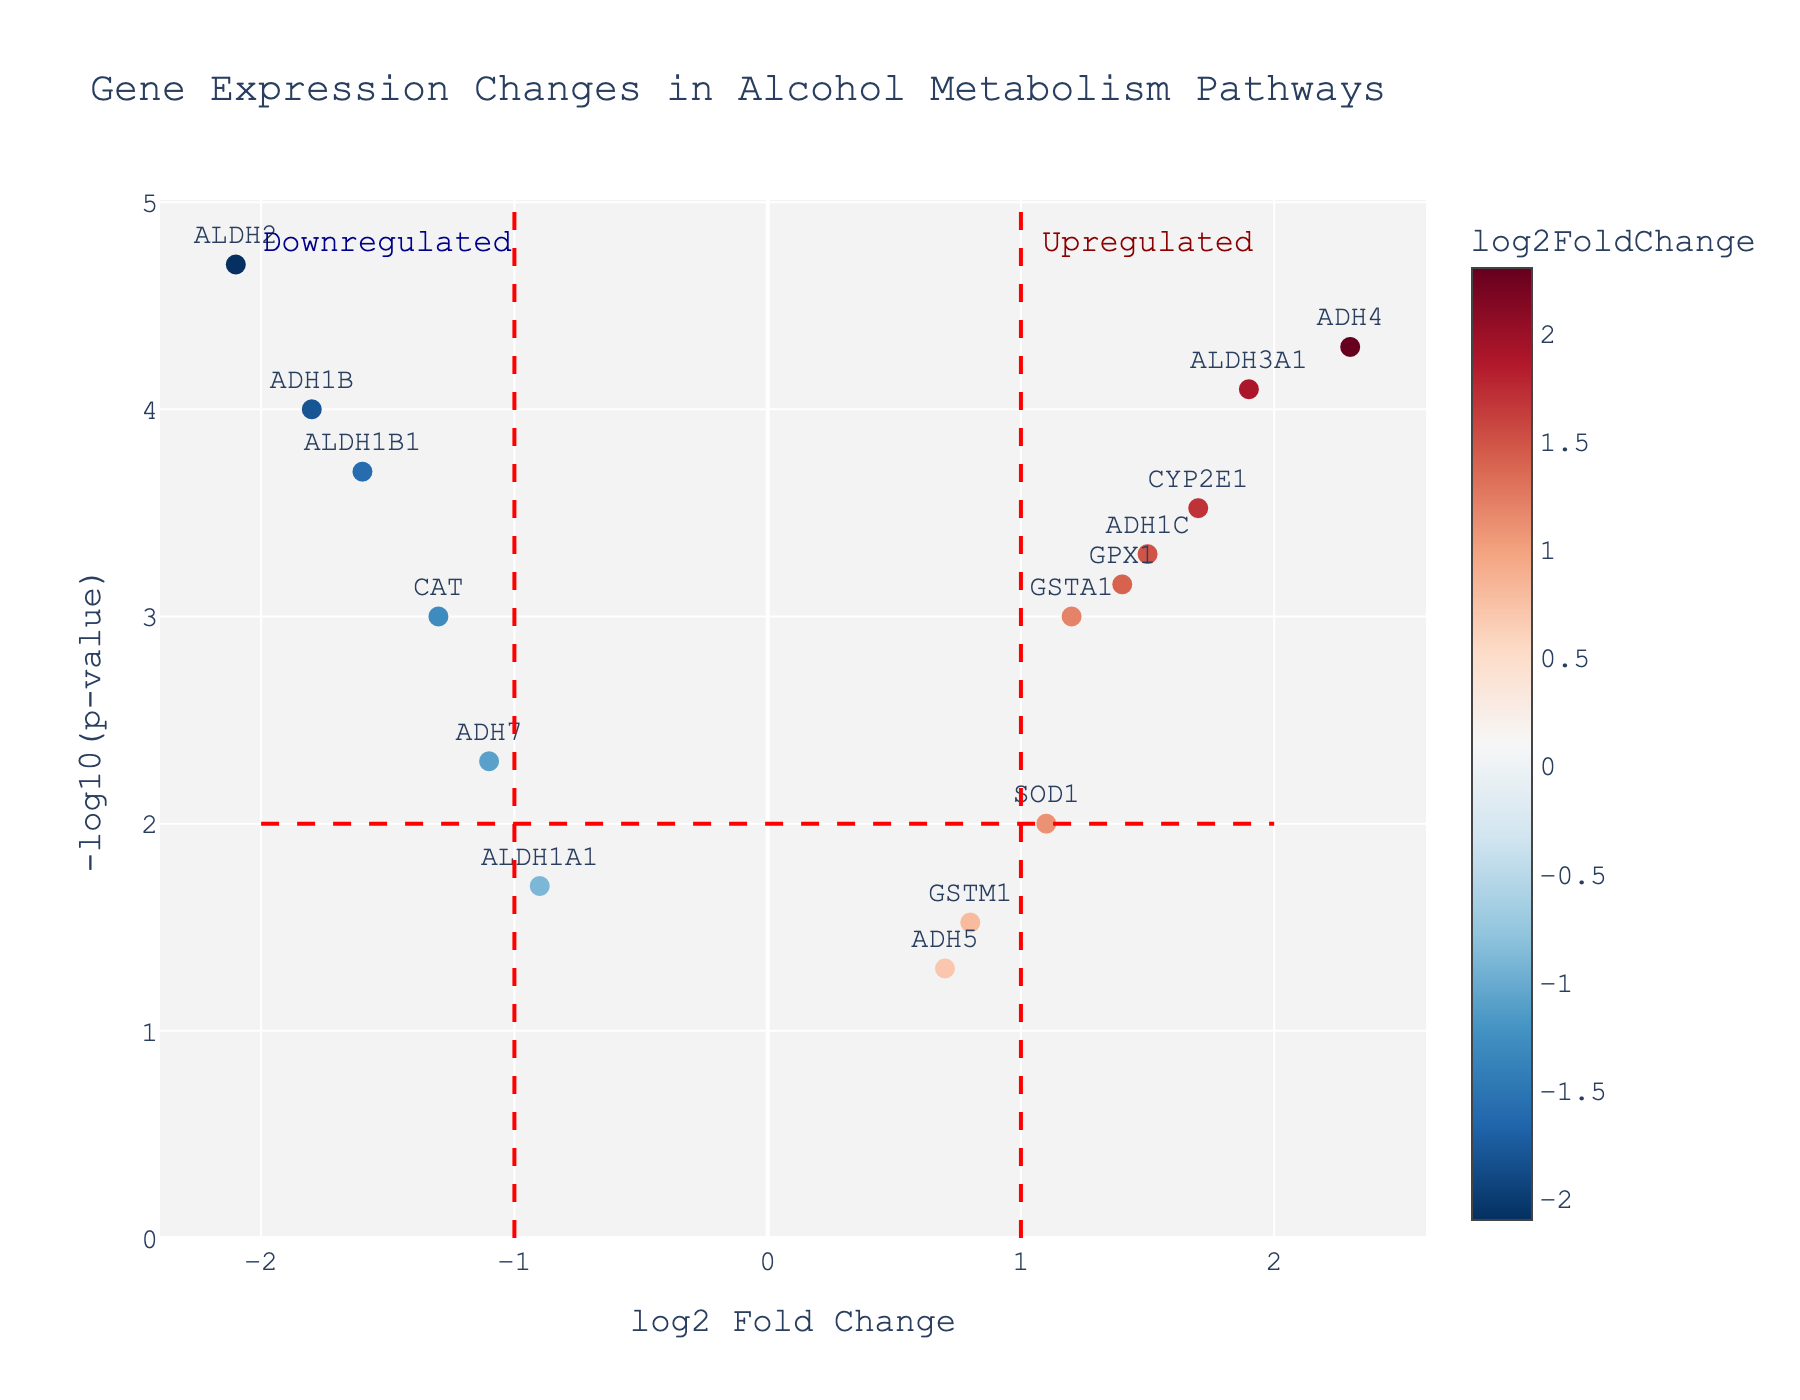What's the title of the plot? The title of the plot is always displayed at the top center of the figure. Here, it says "Gene Expression Changes in Alcohol Metabolism Pathways".
Answer: Gene Expression Changes in Alcohol Metabolism Pathways What do the red dashed lines represent? Red dashed lines on a volcano plot typically indicate significance thresholds. Here, the lines at x=-1 and x=1 represent fold change thresholds, and the line at y=2 represents a p-value threshold of 0.01 (-log10(0.01)).
Answer: Significance thresholds How many genes are upregulated and statistically significant? Upregulated and statistically significant genes are those with a log2FoldChange > 1 and -log10(p-value) > 2. By observing the plot, ADH4, CYP2E1, ADH1C, ALDH3A1, and GPX1 meet these criteria.
Answer: 5 genes Which gene has the highest log2 fold change? The gene with the highest log2 fold change is the one with the highest x-coordinate value. From the plot, we see that ADH4 has the highest log2FoldChange of 2.3.
Answer: ADH4 Are there more upregulated or downregulated genes? To determine this, count the number of genes with positive log2FoldChange (upregulated) and compare it to the number of genes with negative log2FoldChange (downregulated). By examining the points, 7 gene points are upregulated and 8 are downregulated.
Answer: More downregulated What is the p-value of the ADH1B gene? The p-value of a gene can be determined by its y-coordinate which represents -log10(p-value). For ADH1B, the y-coordinate falls around 4, indicating a -log10(p-value) of 4, which translates to p-value = 10^-4.
Answer: 0.0001 Which two genes have the closest log2FoldChange values but different signs? Identify two genes with log2FoldChange values that are numerically similar but opposite in sign. ADH7 (-1.1) and SOD1 (1.1) are the closest in value but have different signs.
Answer: ADH7 and SOD1 Compare the fold changes and p-values of ALDH2 and ALDH1B1. Which gene is more downregulated and more statistically significant? ALDH2 has a log2FoldChange of -2.1 and p-value of 0.00002 (-log10(p-value) = 4.7), while ALDH1B1 has a log2FoldChange of -1.6 and p-value of 0.0002 (-log10(p-value) = 3.7). ALDH2 is both more downregulated and more statistically significant.
Answer: ALDH2 